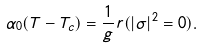Convert formula to latex. <formula><loc_0><loc_0><loc_500><loc_500>\alpha _ { 0 } ( T - T _ { c } ) = \frac { 1 } { g } r ( | \sigma | ^ { 2 } = 0 ) .</formula> 